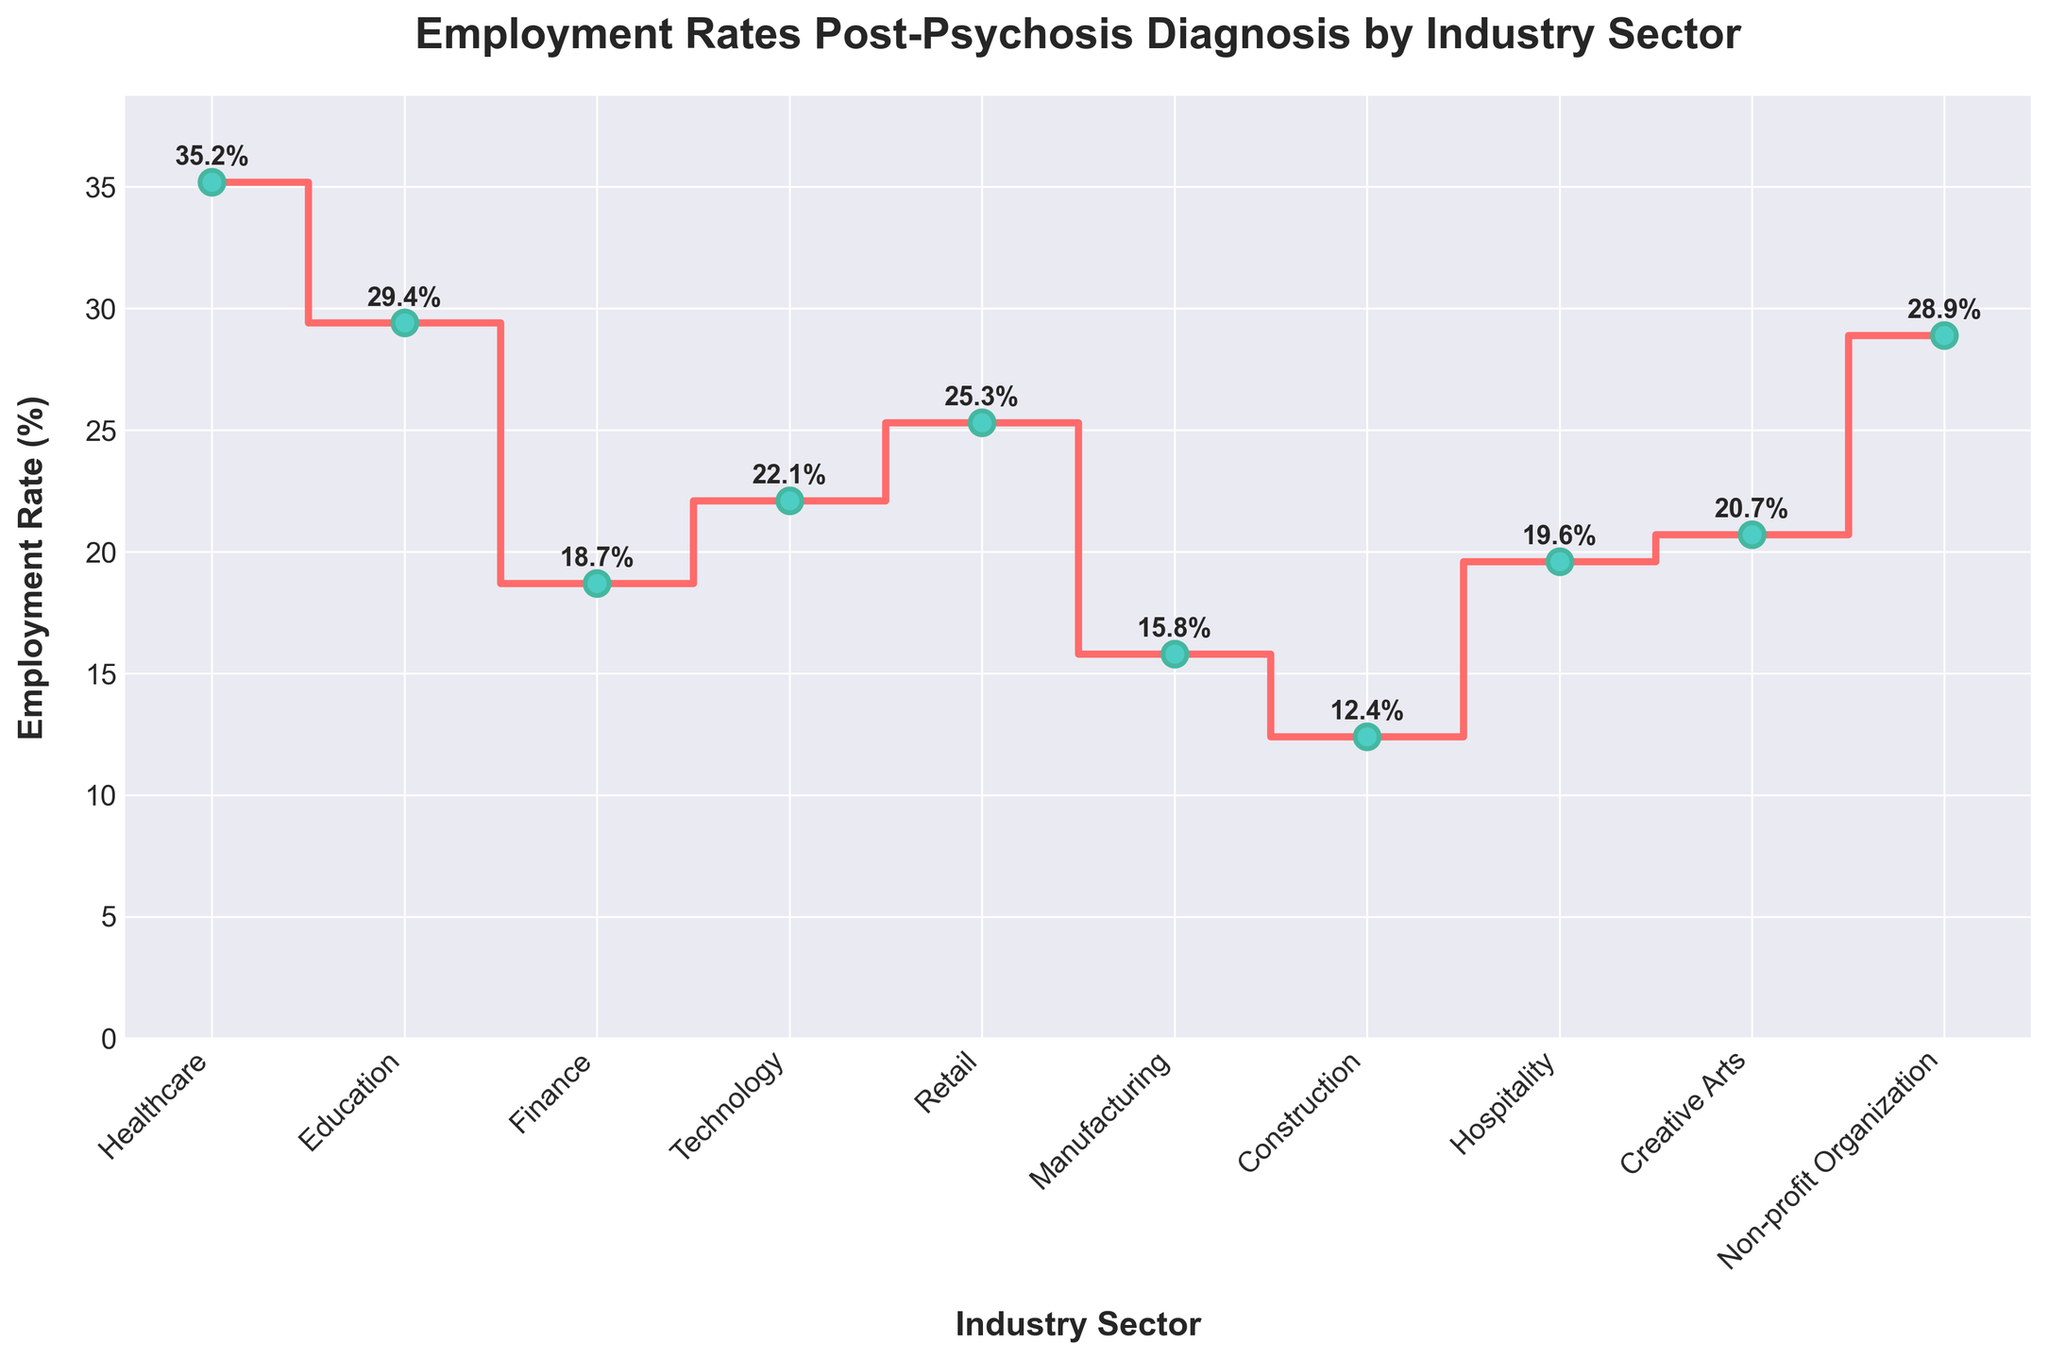What is the employment rate in the Healthcare sector? The employment rate for each sector is shown as a number on top of each plotted point. Look for the data point labeled "Healthcare."
Answer: 35.2% Which sector has the lowest employment rate? The sector with the lowest employment rate has the lowest value on the y-axis. Locate the smallest value among the plotted data points.
Answer: Construction Does Education have a higher employment rate than Finance? Compare the y-axis values for Education and Finance. The sector with the higher value has the higher employment rate.
Answer: Yes Calculate the average employment rate across all sectors. Add all the employment rates: 35.2 + 29.4 + 18.7 + 22.1 + 25.3 + 15.8 + 12.4 + 19.6 + 20.7 + 28.9 = 227.1. Divide by the number of sectors (10).
Answer: 22.71% What is the difference in employment rate between the Healthcare and Technology sectors? Subtract the employment rate of Technology from that of Healthcare: 35.2 - 22.1.
Answer: 13.1% Which sectors have an employment rate above 25%? Identify the plotted sectors with y-axis values above 25%.
Answer: Healthcare, Education, Retail, Non-profit Organization How many sectors have an employment rate below 20%? Count the plotted sectors with y-axis values less than 20%.
Answer: 4 What is the median employment rate across all sectors? First, list the employment rates in ascending order: 12.4, 15.8, 18.7, 19.6, 20.7, 22.1, 25.3, 28.9, 29.4, 35.2. The median is the average of the 5th and 6th values: (20.7 + 22.1) / 2 = 21.4.
Answer: 21.4 Which sector shows the third highest employment rate? List the employment rates in descending order and find the third value: 35.2 (Healthcare), 29.4 (Education), 28.9 (Non-profit Organization).
Answer: Non-profit Organization By what percentage is the employment rate in the Education sector higher than in Construction? Subtract the Construction rate from the Education rate and divide by the Construction rate, then multiply by 100: (29.4 - 12.4) / 12.4 * 100.
Answer: 137.10% 